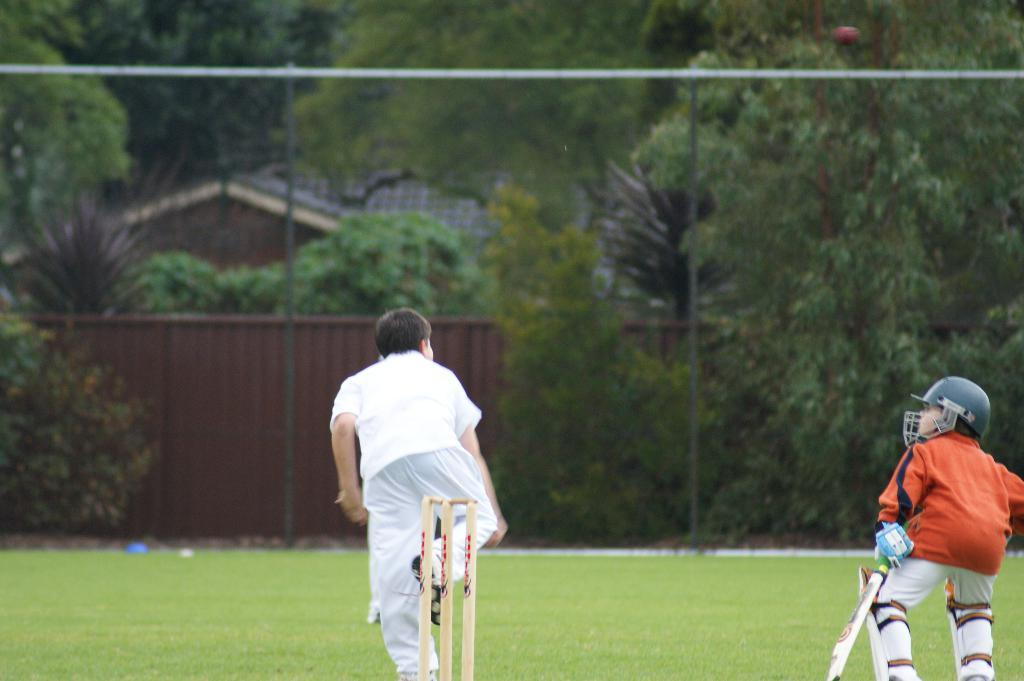What are the persons in the image doing? The persons in the image are standing on the ground. What is one of the persons holding in their hands? One of the persons is holding a bat in their hands. What can be seen in the background of the image? There are buildings, a gate, poles, and trees in the background of the image. What type of error can be seen in the image? There is no error present in the image; it is a clear and accurate representation of the scene. What type of drink is being consumed by the persons in the image? There is no drink visible in the image; the persons are not shown consuming any beverages. 